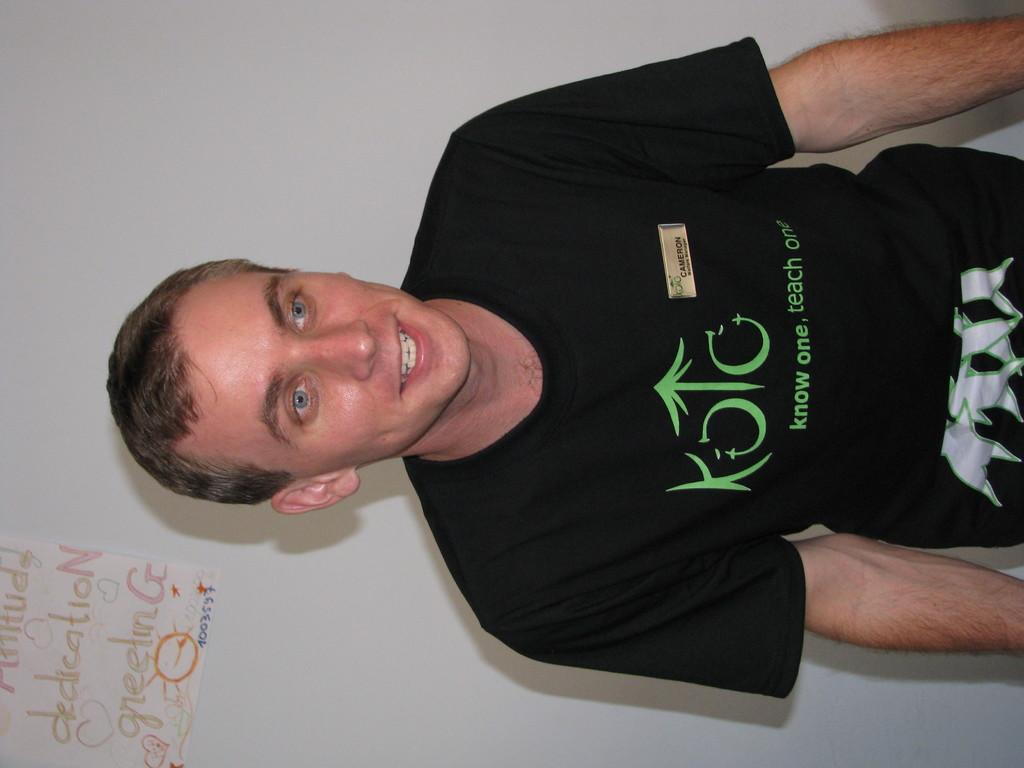Who is present in the image? There is a man in the image. What can be seen in the background of the image? There is a paper with text on it in the background. Where is the paper located in the image? The paper is on the wall. What type of milk is being served in the image? There is no milk present in the image. What kind of badge is the man wearing in the image? The man is not wearing a badge in the image. 